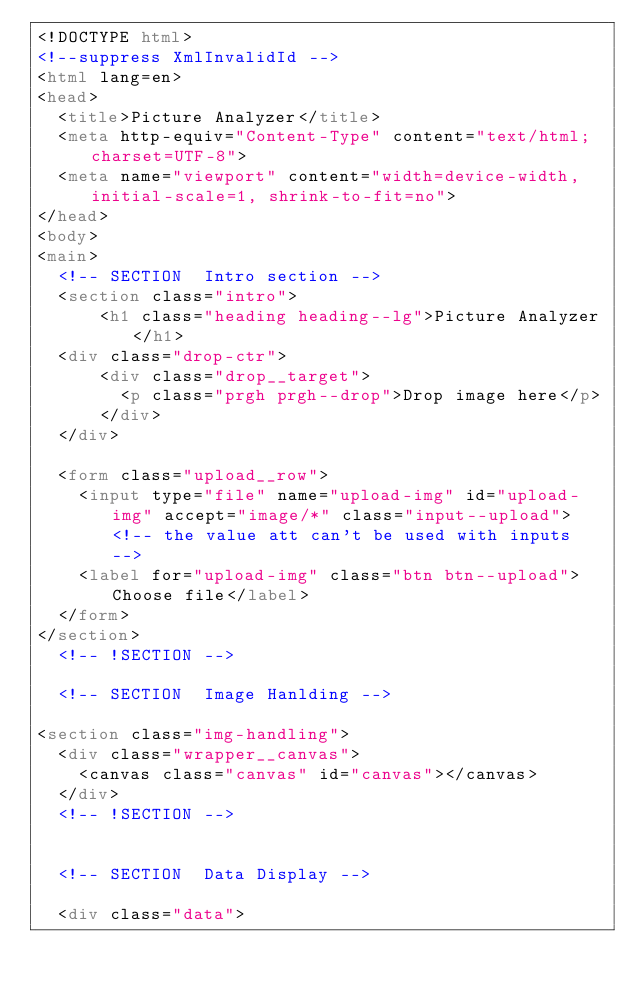<code> <loc_0><loc_0><loc_500><loc_500><_HTML_><!DOCTYPE html>
<!--suppress XmlInvalidId -->
<html lang=en>
<head>
  <title>Picture Analyzer</title>
  <meta http-equiv="Content-Type" content="text/html;charset=UTF-8">
  <meta name="viewport" content="width=device-width, initial-scale=1, shrink-to-fit=no">
</head>
<body>
<main>
  <!-- SECTION  Intro section -->
  <section class="intro">
      <h1 class="heading heading--lg">Picture Analyzer</h1>
  <div class="drop-ctr">
      <div class="drop__target">
        <p class="prgh prgh--drop">Drop image here</p>
      </div>
  </div>

  <form class="upload__row">
    <input type="file" name="upload-img" id="upload-img" accept="image/*" class="input--upload"> <!-- the value att can't be used with inputs -->
    <label for="upload-img" class="btn btn--upload">Choose file</label>
  </form>
</section>
  <!-- !SECTION -->

  <!-- SECTION  Image Hanlding -->

<section class="img-handling">
  <div class="wrapper__canvas">
    <canvas class="canvas" id="canvas"></canvas>
  </div>
  <!-- !SECTION -->


  <!-- SECTION  Data Display -->

  <div class="data"></code> 